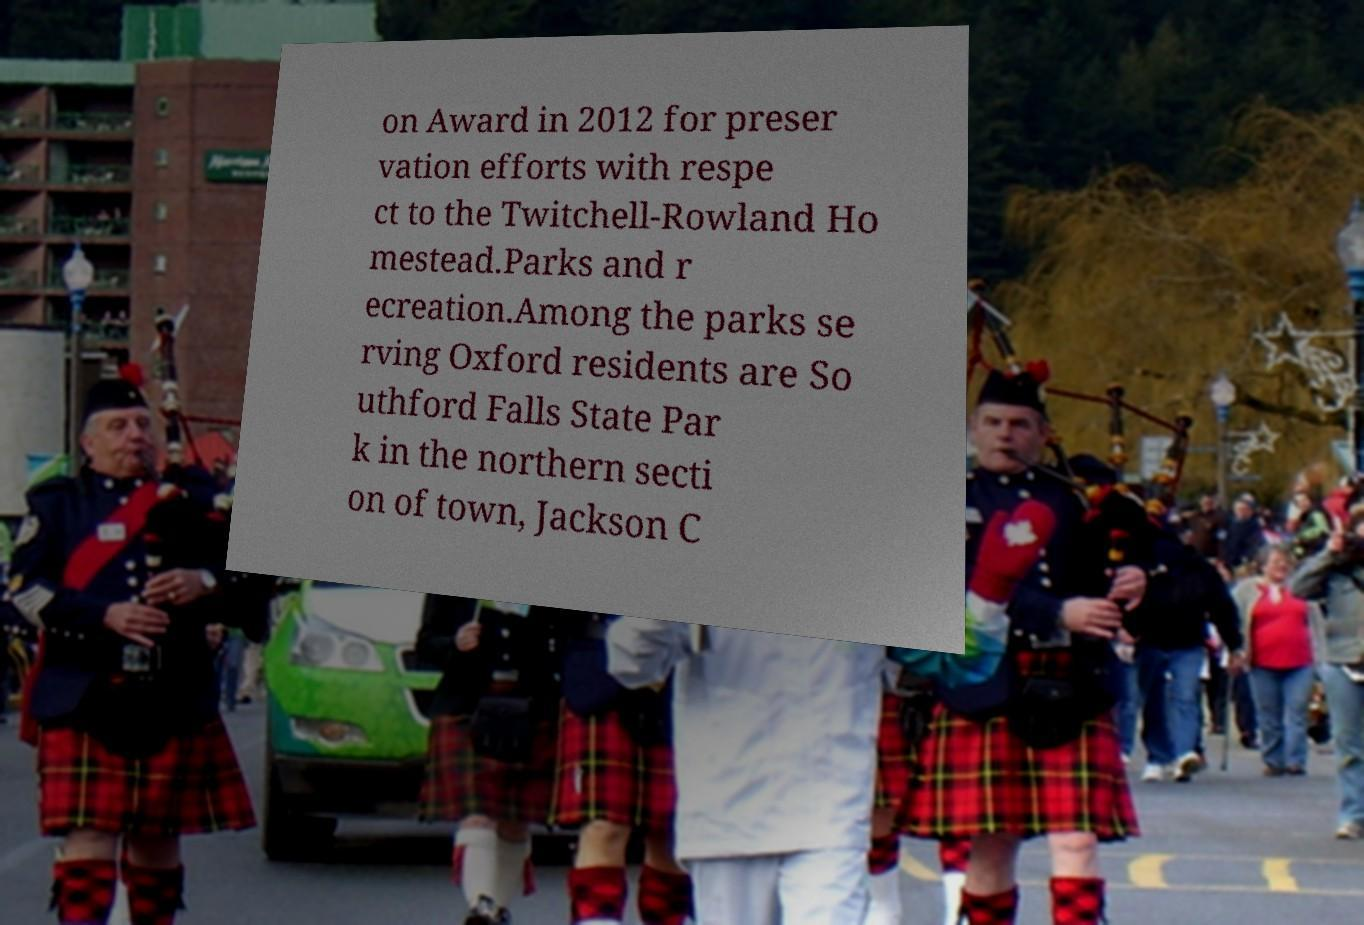Can you accurately transcribe the text from the provided image for me? on Award in 2012 for preser vation efforts with respe ct to the Twitchell-Rowland Ho mestead.Parks and r ecreation.Among the parks se rving Oxford residents are So uthford Falls State Par k in the northern secti on of town, Jackson C 